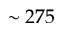Convert formula to latex. <formula><loc_0><loc_0><loc_500><loc_500>\sim 2 7 5</formula> 